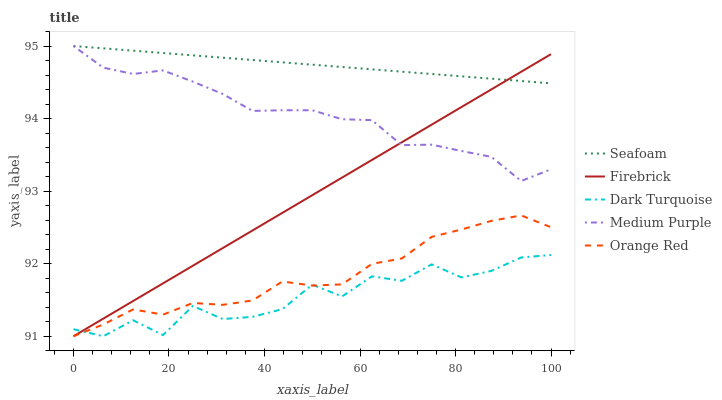Does Dark Turquoise have the minimum area under the curve?
Answer yes or no. Yes. Does Seafoam have the maximum area under the curve?
Answer yes or no. Yes. Does Firebrick have the minimum area under the curve?
Answer yes or no. No. Does Firebrick have the maximum area under the curve?
Answer yes or no. No. Is Firebrick the smoothest?
Answer yes or no. Yes. Is Dark Turquoise the roughest?
Answer yes or no. Yes. Is Dark Turquoise the smoothest?
Answer yes or no. No. Is Firebrick the roughest?
Answer yes or no. No. Does Seafoam have the lowest value?
Answer yes or no. No. Does Seafoam have the highest value?
Answer yes or no. Yes. Does Firebrick have the highest value?
Answer yes or no. No. Is Dark Turquoise less than Seafoam?
Answer yes or no. Yes. Is Medium Purple greater than Orange Red?
Answer yes or no. Yes. Does Firebrick intersect Orange Red?
Answer yes or no. Yes. Is Firebrick less than Orange Red?
Answer yes or no. No. Is Firebrick greater than Orange Red?
Answer yes or no. No. Does Dark Turquoise intersect Seafoam?
Answer yes or no. No. 